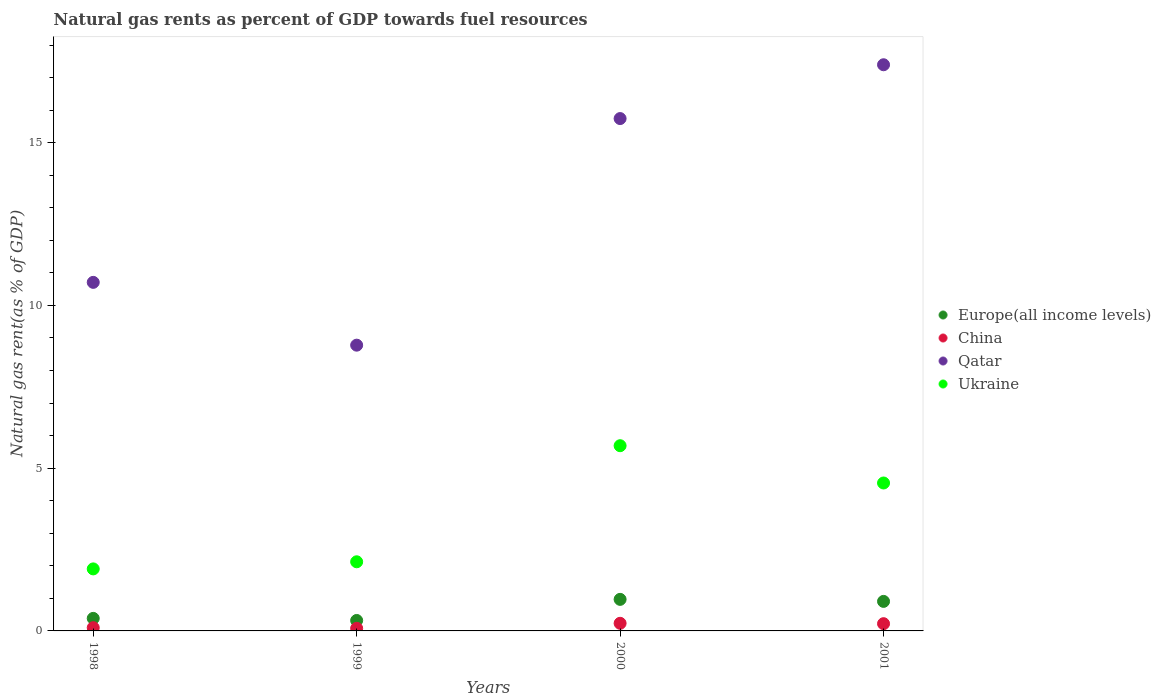How many different coloured dotlines are there?
Make the answer very short. 4. What is the natural gas rent in Ukraine in 2001?
Offer a very short reply. 4.54. Across all years, what is the maximum natural gas rent in China?
Offer a terse response. 0.23. Across all years, what is the minimum natural gas rent in Ukraine?
Your response must be concise. 1.91. In which year was the natural gas rent in Qatar minimum?
Your response must be concise. 1999. What is the total natural gas rent in Europe(all income levels) in the graph?
Your answer should be compact. 2.58. What is the difference between the natural gas rent in China in 1998 and that in 1999?
Offer a very short reply. 0.02. What is the difference between the natural gas rent in Ukraine in 2000 and the natural gas rent in China in 2001?
Offer a very short reply. 5.47. What is the average natural gas rent in Europe(all income levels) per year?
Make the answer very short. 0.65. In the year 1999, what is the difference between the natural gas rent in Qatar and natural gas rent in China?
Offer a terse response. 8.7. What is the ratio of the natural gas rent in Europe(all income levels) in 1999 to that in 2000?
Provide a succinct answer. 0.33. Is the natural gas rent in Qatar in 1998 less than that in 2001?
Provide a succinct answer. Yes. Is the difference between the natural gas rent in Qatar in 1999 and 2000 greater than the difference between the natural gas rent in China in 1999 and 2000?
Offer a very short reply. No. What is the difference between the highest and the second highest natural gas rent in Ukraine?
Ensure brevity in your answer.  1.15. What is the difference between the highest and the lowest natural gas rent in Ukraine?
Your answer should be compact. 3.79. Is the sum of the natural gas rent in China in 1999 and 2000 greater than the maximum natural gas rent in Qatar across all years?
Ensure brevity in your answer.  No. Does the natural gas rent in Europe(all income levels) monotonically increase over the years?
Ensure brevity in your answer.  No. How many dotlines are there?
Provide a succinct answer. 4. What is the difference between two consecutive major ticks on the Y-axis?
Make the answer very short. 5. Where does the legend appear in the graph?
Make the answer very short. Center right. How many legend labels are there?
Make the answer very short. 4. How are the legend labels stacked?
Make the answer very short. Vertical. What is the title of the graph?
Offer a very short reply. Natural gas rents as percent of GDP towards fuel resources. What is the label or title of the Y-axis?
Provide a short and direct response. Natural gas rent(as % of GDP). What is the Natural gas rent(as % of GDP) of Europe(all income levels) in 1998?
Provide a short and direct response. 0.38. What is the Natural gas rent(as % of GDP) of China in 1998?
Ensure brevity in your answer.  0.1. What is the Natural gas rent(as % of GDP) in Qatar in 1998?
Your answer should be very brief. 10.71. What is the Natural gas rent(as % of GDP) of Ukraine in 1998?
Your answer should be compact. 1.91. What is the Natural gas rent(as % of GDP) of Europe(all income levels) in 1999?
Offer a very short reply. 0.32. What is the Natural gas rent(as % of GDP) in China in 1999?
Provide a short and direct response. 0.08. What is the Natural gas rent(as % of GDP) of Qatar in 1999?
Your answer should be very brief. 8.78. What is the Natural gas rent(as % of GDP) in Ukraine in 1999?
Provide a succinct answer. 2.12. What is the Natural gas rent(as % of GDP) of Europe(all income levels) in 2000?
Give a very brief answer. 0.97. What is the Natural gas rent(as % of GDP) in China in 2000?
Your response must be concise. 0.23. What is the Natural gas rent(as % of GDP) in Qatar in 2000?
Offer a very short reply. 15.74. What is the Natural gas rent(as % of GDP) of Ukraine in 2000?
Give a very brief answer. 5.69. What is the Natural gas rent(as % of GDP) in Europe(all income levels) in 2001?
Offer a very short reply. 0.91. What is the Natural gas rent(as % of GDP) of China in 2001?
Your response must be concise. 0.22. What is the Natural gas rent(as % of GDP) of Qatar in 2001?
Offer a terse response. 17.39. What is the Natural gas rent(as % of GDP) of Ukraine in 2001?
Your answer should be very brief. 4.54. Across all years, what is the maximum Natural gas rent(as % of GDP) of Europe(all income levels)?
Ensure brevity in your answer.  0.97. Across all years, what is the maximum Natural gas rent(as % of GDP) of China?
Provide a short and direct response. 0.23. Across all years, what is the maximum Natural gas rent(as % of GDP) in Qatar?
Make the answer very short. 17.39. Across all years, what is the maximum Natural gas rent(as % of GDP) in Ukraine?
Provide a short and direct response. 5.69. Across all years, what is the minimum Natural gas rent(as % of GDP) in Europe(all income levels)?
Make the answer very short. 0.32. Across all years, what is the minimum Natural gas rent(as % of GDP) in China?
Keep it short and to the point. 0.08. Across all years, what is the minimum Natural gas rent(as % of GDP) of Qatar?
Offer a very short reply. 8.78. Across all years, what is the minimum Natural gas rent(as % of GDP) of Ukraine?
Provide a succinct answer. 1.91. What is the total Natural gas rent(as % of GDP) of Europe(all income levels) in the graph?
Offer a terse response. 2.58. What is the total Natural gas rent(as % of GDP) of China in the graph?
Provide a succinct answer. 0.64. What is the total Natural gas rent(as % of GDP) in Qatar in the graph?
Your response must be concise. 52.62. What is the total Natural gas rent(as % of GDP) in Ukraine in the graph?
Offer a very short reply. 14.26. What is the difference between the Natural gas rent(as % of GDP) of Europe(all income levels) in 1998 and that in 1999?
Offer a very short reply. 0.06. What is the difference between the Natural gas rent(as % of GDP) of China in 1998 and that in 1999?
Your answer should be compact. 0.02. What is the difference between the Natural gas rent(as % of GDP) in Qatar in 1998 and that in 1999?
Ensure brevity in your answer.  1.93. What is the difference between the Natural gas rent(as % of GDP) of Ukraine in 1998 and that in 1999?
Provide a succinct answer. -0.22. What is the difference between the Natural gas rent(as % of GDP) of Europe(all income levels) in 1998 and that in 2000?
Your answer should be compact. -0.58. What is the difference between the Natural gas rent(as % of GDP) in China in 1998 and that in 2000?
Provide a short and direct response. -0.13. What is the difference between the Natural gas rent(as % of GDP) in Qatar in 1998 and that in 2000?
Make the answer very short. -5.03. What is the difference between the Natural gas rent(as % of GDP) of Ukraine in 1998 and that in 2000?
Offer a very short reply. -3.79. What is the difference between the Natural gas rent(as % of GDP) in Europe(all income levels) in 1998 and that in 2001?
Provide a short and direct response. -0.52. What is the difference between the Natural gas rent(as % of GDP) of China in 1998 and that in 2001?
Offer a very short reply. -0.12. What is the difference between the Natural gas rent(as % of GDP) in Qatar in 1998 and that in 2001?
Offer a terse response. -6.69. What is the difference between the Natural gas rent(as % of GDP) of Ukraine in 1998 and that in 2001?
Offer a terse response. -2.64. What is the difference between the Natural gas rent(as % of GDP) in Europe(all income levels) in 1999 and that in 2000?
Provide a succinct answer. -0.65. What is the difference between the Natural gas rent(as % of GDP) in China in 1999 and that in 2000?
Your response must be concise. -0.15. What is the difference between the Natural gas rent(as % of GDP) in Qatar in 1999 and that in 2000?
Your answer should be compact. -6.96. What is the difference between the Natural gas rent(as % of GDP) of Ukraine in 1999 and that in 2000?
Your answer should be compact. -3.57. What is the difference between the Natural gas rent(as % of GDP) in Europe(all income levels) in 1999 and that in 2001?
Provide a succinct answer. -0.59. What is the difference between the Natural gas rent(as % of GDP) of China in 1999 and that in 2001?
Provide a succinct answer. -0.14. What is the difference between the Natural gas rent(as % of GDP) of Qatar in 1999 and that in 2001?
Make the answer very short. -8.62. What is the difference between the Natural gas rent(as % of GDP) in Ukraine in 1999 and that in 2001?
Offer a very short reply. -2.42. What is the difference between the Natural gas rent(as % of GDP) in Europe(all income levels) in 2000 and that in 2001?
Keep it short and to the point. 0.06. What is the difference between the Natural gas rent(as % of GDP) of China in 2000 and that in 2001?
Give a very brief answer. 0.01. What is the difference between the Natural gas rent(as % of GDP) of Qatar in 2000 and that in 2001?
Your answer should be very brief. -1.65. What is the difference between the Natural gas rent(as % of GDP) of Ukraine in 2000 and that in 2001?
Your answer should be compact. 1.15. What is the difference between the Natural gas rent(as % of GDP) of Europe(all income levels) in 1998 and the Natural gas rent(as % of GDP) of China in 1999?
Provide a succinct answer. 0.31. What is the difference between the Natural gas rent(as % of GDP) in Europe(all income levels) in 1998 and the Natural gas rent(as % of GDP) in Qatar in 1999?
Provide a succinct answer. -8.39. What is the difference between the Natural gas rent(as % of GDP) of Europe(all income levels) in 1998 and the Natural gas rent(as % of GDP) of Ukraine in 1999?
Offer a terse response. -1.74. What is the difference between the Natural gas rent(as % of GDP) of China in 1998 and the Natural gas rent(as % of GDP) of Qatar in 1999?
Your response must be concise. -8.68. What is the difference between the Natural gas rent(as % of GDP) in China in 1998 and the Natural gas rent(as % of GDP) in Ukraine in 1999?
Your answer should be very brief. -2.02. What is the difference between the Natural gas rent(as % of GDP) in Qatar in 1998 and the Natural gas rent(as % of GDP) in Ukraine in 1999?
Make the answer very short. 8.58. What is the difference between the Natural gas rent(as % of GDP) of Europe(all income levels) in 1998 and the Natural gas rent(as % of GDP) of China in 2000?
Offer a very short reply. 0.15. What is the difference between the Natural gas rent(as % of GDP) in Europe(all income levels) in 1998 and the Natural gas rent(as % of GDP) in Qatar in 2000?
Give a very brief answer. -15.36. What is the difference between the Natural gas rent(as % of GDP) of Europe(all income levels) in 1998 and the Natural gas rent(as % of GDP) of Ukraine in 2000?
Your answer should be compact. -5.31. What is the difference between the Natural gas rent(as % of GDP) in China in 1998 and the Natural gas rent(as % of GDP) in Qatar in 2000?
Provide a short and direct response. -15.64. What is the difference between the Natural gas rent(as % of GDP) of China in 1998 and the Natural gas rent(as % of GDP) of Ukraine in 2000?
Ensure brevity in your answer.  -5.59. What is the difference between the Natural gas rent(as % of GDP) in Qatar in 1998 and the Natural gas rent(as % of GDP) in Ukraine in 2000?
Offer a very short reply. 5.02. What is the difference between the Natural gas rent(as % of GDP) of Europe(all income levels) in 1998 and the Natural gas rent(as % of GDP) of China in 2001?
Provide a succinct answer. 0.16. What is the difference between the Natural gas rent(as % of GDP) in Europe(all income levels) in 1998 and the Natural gas rent(as % of GDP) in Qatar in 2001?
Make the answer very short. -17.01. What is the difference between the Natural gas rent(as % of GDP) of Europe(all income levels) in 1998 and the Natural gas rent(as % of GDP) of Ukraine in 2001?
Ensure brevity in your answer.  -4.16. What is the difference between the Natural gas rent(as % of GDP) in China in 1998 and the Natural gas rent(as % of GDP) in Qatar in 2001?
Your answer should be compact. -17.3. What is the difference between the Natural gas rent(as % of GDP) in China in 1998 and the Natural gas rent(as % of GDP) in Ukraine in 2001?
Offer a terse response. -4.45. What is the difference between the Natural gas rent(as % of GDP) in Qatar in 1998 and the Natural gas rent(as % of GDP) in Ukraine in 2001?
Your response must be concise. 6.16. What is the difference between the Natural gas rent(as % of GDP) in Europe(all income levels) in 1999 and the Natural gas rent(as % of GDP) in China in 2000?
Provide a succinct answer. 0.09. What is the difference between the Natural gas rent(as % of GDP) in Europe(all income levels) in 1999 and the Natural gas rent(as % of GDP) in Qatar in 2000?
Your response must be concise. -15.42. What is the difference between the Natural gas rent(as % of GDP) in Europe(all income levels) in 1999 and the Natural gas rent(as % of GDP) in Ukraine in 2000?
Make the answer very short. -5.37. What is the difference between the Natural gas rent(as % of GDP) in China in 1999 and the Natural gas rent(as % of GDP) in Qatar in 2000?
Offer a terse response. -15.66. What is the difference between the Natural gas rent(as % of GDP) of China in 1999 and the Natural gas rent(as % of GDP) of Ukraine in 2000?
Provide a succinct answer. -5.61. What is the difference between the Natural gas rent(as % of GDP) of Qatar in 1999 and the Natural gas rent(as % of GDP) of Ukraine in 2000?
Offer a very short reply. 3.09. What is the difference between the Natural gas rent(as % of GDP) of Europe(all income levels) in 1999 and the Natural gas rent(as % of GDP) of China in 2001?
Provide a succinct answer. 0.1. What is the difference between the Natural gas rent(as % of GDP) in Europe(all income levels) in 1999 and the Natural gas rent(as % of GDP) in Qatar in 2001?
Your answer should be very brief. -17.07. What is the difference between the Natural gas rent(as % of GDP) of Europe(all income levels) in 1999 and the Natural gas rent(as % of GDP) of Ukraine in 2001?
Your response must be concise. -4.22. What is the difference between the Natural gas rent(as % of GDP) in China in 1999 and the Natural gas rent(as % of GDP) in Qatar in 2001?
Ensure brevity in your answer.  -17.31. What is the difference between the Natural gas rent(as % of GDP) of China in 1999 and the Natural gas rent(as % of GDP) of Ukraine in 2001?
Give a very brief answer. -4.47. What is the difference between the Natural gas rent(as % of GDP) in Qatar in 1999 and the Natural gas rent(as % of GDP) in Ukraine in 2001?
Give a very brief answer. 4.23. What is the difference between the Natural gas rent(as % of GDP) of Europe(all income levels) in 2000 and the Natural gas rent(as % of GDP) of China in 2001?
Ensure brevity in your answer.  0.75. What is the difference between the Natural gas rent(as % of GDP) of Europe(all income levels) in 2000 and the Natural gas rent(as % of GDP) of Qatar in 2001?
Offer a terse response. -16.43. What is the difference between the Natural gas rent(as % of GDP) in Europe(all income levels) in 2000 and the Natural gas rent(as % of GDP) in Ukraine in 2001?
Your answer should be very brief. -3.58. What is the difference between the Natural gas rent(as % of GDP) in China in 2000 and the Natural gas rent(as % of GDP) in Qatar in 2001?
Your answer should be very brief. -17.16. What is the difference between the Natural gas rent(as % of GDP) in China in 2000 and the Natural gas rent(as % of GDP) in Ukraine in 2001?
Offer a terse response. -4.31. What is the difference between the Natural gas rent(as % of GDP) of Qatar in 2000 and the Natural gas rent(as % of GDP) of Ukraine in 2001?
Provide a succinct answer. 11.2. What is the average Natural gas rent(as % of GDP) in Europe(all income levels) per year?
Give a very brief answer. 0.65. What is the average Natural gas rent(as % of GDP) of China per year?
Provide a short and direct response. 0.16. What is the average Natural gas rent(as % of GDP) in Qatar per year?
Keep it short and to the point. 13.16. What is the average Natural gas rent(as % of GDP) of Ukraine per year?
Provide a short and direct response. 3.57. In the year 1998, what is the difference between the Natural gas rent(as % of GDP) of Europe(all income levels) and Natural gas rent(as % of GDP) of China?
Offer a terse response. 0.29. In the year 1998, what is the difference between the Natural gas rent(as % of GDP) in Europe(all income levels) and Natural gas rent(as % of GDP) in Qatar?
Your answer should be very brief. -10.32. In the year 1998, what is the difference between the Natural gas rent(as % of GDP) of Europe(all income levels) and Natural gas rent(as % of GDP) of Ukraine?
Keep it short and to the point. -1.52. In the year 1998, what is the difference between the Natural gas rent(as % of GDP) in China and Natural gas rent(as % of GDP) in Qatar?
Your response must be concise. -10.61. In the year 1998, what is the difference between the Natural gas rent(as % of GDP) in China and Natural gas rent(as % of GDP) in Ukraine?
Your response must be concise. -1.81. In the year 1998, what is the difference between the Natural gas rent(as % of GDP) in Qatar and Natural gas rent(as % of GDP) in Ukraine?
Keep it short and to the point. 8.8. In the year 1999, what is the difference between the Natural gas rent(as % of GDP) of Europe(all income levels) and Natural gas rent(as % of GDP) of China?
Provide a succinct answer. 0.24. In the year 1999, what is the difference between the Natural gas rent(as % of GDP) in Europe(all income levels) and Natural gas rent(as % of GDP) in Qatar?
Your answer should be very brief. -8.46. In the year 1999, what is the difference between the Natural gas rent(as % of GDP) in Europe(all income levels) and Natural gas rent(as % of GDP) in Ukraine?
Offer a very short reply. -1.8. In the year 1999, what is the difference between the Natural gas rent(as % of GDP) of China and Natural gas rent(as % of GDP) of Qatar?
Offer a very short reply. -8.7. In the year 1999, what is the difference between the Natural gas rent(as % of GDP) of China and Natural gas rent(as % of GDP) of Ukraine?
Keep it short and to the point. -2.04. In the year 1999, what is the difference between the Natural gas rent(as % of GDP) in Qatar and Natural gas rent(as % of GDP) in Ukraine?
Ensure brevity in your answer.  6.66. In the year 2000, what is the difference between the Natural gas rent(as % of GDP) in Europe(all income levels) and Natural gas rent(as % of GDP) in China?
Your response must be concise. 0.74. In the year 2000, what is the difference between the Natural gas rent(as % of GDP) of Europe(all income levels) and Natural gas rent(as % of GDP) of Qatar?
Your response must be concise. -14.77. In the year 2000, what is the difference between the Natural gas rent(as % of GDP) in Europe(all income levels) and Natural gas rent(as % of GDP) in Ukraine?
Ensure brevity in your answer.  -4.72. In the year 2000, what is the difference between the Natural gas rent(as % of GDP) of China and Natural gas rent(as % of GDP) of Qatar?
Keep it short and to the point. -15.51. In the year 2000, what is the difference between the Natural gas rent(as % of GDP) in China and Natural gas rent(as % of GDP) in Ukraine?
Your response must be concise. -5.46. In the year 2000, what is the difference between the Natural gas rent(as % of GDP) of Qatar and Natural gas rent(as % of GDP) of Ukraine?
Offer a very short reply. 10.05. In the year 2001, what is the difference between the Natural gas rent(as % of GDP) in Europe(all income levels) and Natural gas rent(as % of GDP) in China?
Provide a succinct answer. 0.69. In the year 2001, what is the difference between the Natural gas rent(as % of GDP) of Europe(all income levels) and Natural gas rent(as % of GDP) of Qatar?
Offer a terse response. -16.49. In the year 2001, what is the difference between the Natural gas rent(as % of GDP) of Europe(all income levels) and Natural gas rent(as % of GDP) of Ukraine?
Make the answer very short. -3.64. In the year 2001, what is the difference between the Natural gas rent(as % of GDP) of China and Natural gas rent(as % of GDP) of Qatar?
Make the answer very short. -17.17. In the year 2001, what is the difference between the Natural gas rent(as % of GDP) of China and Natural gas rent(as % of GDP) of Ukraine?
Offer a terse response. -4.32. In the year 2001, what is the difference between the Natural gas rent(as % of GDP) of Qatar and Natural gas rent(as % of GDP) of Ukraine?
Offer a terse response. 12.85. What is the ratio of the Natural gas rent(as % of GDP) in Europe(all income levels) in 1998 to that in 1999?
Offer a terse response. 1.2. What is the ratio of the Natural gas rent(as % of GDP) of China in 1998 to that in 1999?
Your answer should be compact. 1.24. What is the ratio of the Natural gas rent(as % of GDP) in Qatar in 1998 to that in 1999?
Your answer should be compact. 1.22. What is the ratio of the Natural gas rent(as % of GDP) in Ukraine in 1998 to that in 1999?
Your response must be concise. 0.9. What is the ratio of the Natural gas rent(as % of GDP) of Europe(all income levels) in 1998 to that in 2000?
Your response must be concise. 0.4. What is the ratio of the Natural gas rent(as % of GDP) of China in 1998 to that in 2000?
Provide a short and direct response. 0.42. What is the ratio of the Natural gas rent(as % of GDP) in Qatar in 1998 to that in 2000?
Give a very brief answer. 0.68. What is the ratio of the Natural gas rent(as % of GDP) in Ukraine in 1998 to that in 2000?
Your answer should be compact. 0.33. What is the ratio of the Natural gas rent(as % of GDP) of Europe(all income levels) in 1998 to that in 2001?
Provide a short and direct response. 0.42. What is the ratio of the Natural gas rent(as % of GDP) in China in 1998 to that in 2001?
Offer a very short reply. 0.45. What is the ratio of the Natural gas rent(as % of GDP) in Qatar in 1998 to that in 2001?
Give a very brief answer. 0.62. What is the ratio of the Natural gas rent(as % of GDP) in Ukraine in 1998 to that in 2001?
Provide a succinct answer. 0.42. What is the ratio of the Natural gas rent(as % of GDP) in Europe(all income levels) in 1999 to that in 2000?
Your answer should be compact. 0.33. What is the ratio of the Natural gas rent(as % of GDP) of China in 1999 to that in 2000?
Make the answer very short. 0.34. What is the ratio of the Natural gas rent(as % of GDP) in Qatar in 1999 to that in 2000?
Make the answer very short. 0.56. What is the ratio of the Natural gas rent(as % of GDP) of Ukraine in 1999 to that in 2000?
Offer a terse response. 0.37. What is the ratio of the Natural gas rent(as % of GDP) in Europe(all income levels) in 1999 to that in 2001?
Offer a terse response. 0.35. What is the ratio of the Natural gas rent(as % of GDP) in China in 1999 to that in 2001?
Make the answer very short. 0.36. What is the ratio of the Natural gas rent(as % of GDP) in Qatar in 1999 to that in 2001?
Offer a terse response. 0.5. What is the ratio of the Natural gas rent(as % of GDP) in Ukraine in 1999 to that in 2001?
Offer a terse response. 0.47. What is the ratio of the Natural gas rent(as % of GDP) of Europe(all income levels) in 2000 to that in 2001?
Your response must be concise. 1.07. What is the ratio of the Natural gas rent(as % of GDP) in China in 2000 to that in 2001?
Your response must be concise. 1.05. What is the ratio of the Natural gas rent(as % of GDP) of Qatar in 2000 to that in 2001?
Provide a short and direct response. 0.91. What is the ratio of the Natural gas rent(as % of GDP) of Ukraine in 2000 to that in 2001?
Your response must be concise. 1.25. What is the difference between the highest and the second highest Natural gas rent(as % of GDP) in Europe(all income levels)?
Give a very brief answer. 0.06. What is the difference between the highest and the second highest Natural gas rent(as % of GDP) of China?
Keep it short and to the point. 0.01. What is the difference between the highest and the second highest Natural gas rent(as % of GDP) in Qatar?
Your answer should be very brief. 1.65. What is the difference between the highest and the second highest Natural gas rent(as % of GDP) in Ukraine?
Give a very brief answer. 1.15. What is the difference between the highest and the lowest Natural gas rent(as % of GDP) of Europe(all income levels)?
Your answer should be compact. 0.65. What is the difference between the highest and the lowest Natural gas rent(as % of GDP) in China?
Your answer should be very brief. 0.15. What is the difference between the highest and the lowest Natural gas rent(as % of GDP) in Qatar?
Your answer should be compact. 8.62. What is the difference between the highest and the lowest Natural gas rent(as % of GDP) of Ukraine?
Offer a terse response. 3.79. 